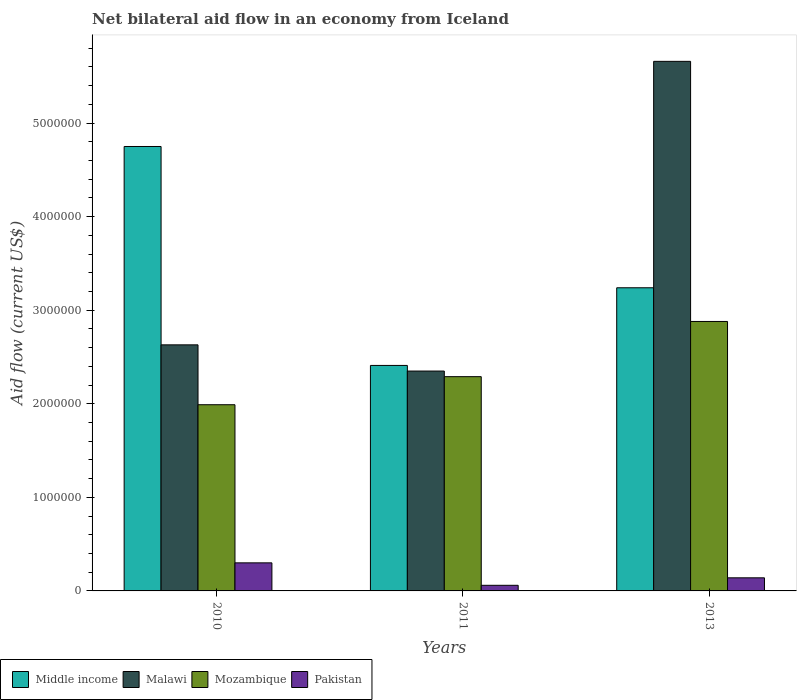How many different coloured bars are there?
Your response must be concise. 4. How many bars are there on the 1st tick from the left?
Provide a short and direct response. 4. How many bars are there on the 3rd tick from the right?
Keep it short and to the point. 4. What is the label of the 3rd group of bars from the left?
Provide a short and direct response. 2013. In how many cases, is the number of bars for a given year not equal to the number of legend labels?
Keep it short and to the point. 0. What is the net bilateral aid flow in Malawi in 2013?
Offer a terse response. 5.66e+06. Across all years, what is the maximum net bilateral aid flow in Malawi?
Your answer should be compact. 5.66e+06. What is the total net bilateral aid flow in Mozambique in the graph?
Your answer should be very brief. 7.16e+06. What is the difference between the net bilateral aid flow in Mozambique in 2010 and the net bilateral aid flow in Malawi in 2013?
Your response must be concise. -3.67e+06. What is the average net bilateral aid flow in Mozambique per year?
Your answer should be very brief. 2.39e+06. In the year 2010, what is the difference between the net bilateral aid flow in Mozambique and net bilateral aid flow in Malawi?
Provide a short and direct response. -6.40e+05. What is the ratio of the net bilateral aid flow in Malawi in 2010 to that in 2013?
Give a very brief answer. 0.46. Is the net bilateral aid flow in Mozambique in 2011 less than that in 2013?
Offer a terse response. Yes. Is the difference between the net bilateral aid flow in Mozambique in 2010 and 2011 greater than the difference between the net bilateral aid flow in Malawi in 2010 and 2011?
Make the answer very short. No. What is the difference between the highest and the second highest net bilateral aid flow in Mozambique?
Provide a succinct answer. 5.90e+05. In how many years, is the net bilateral aid flow in Mozambique greater than the average net bilateral aid flow in Mozambique taken over all years?
Offer a terse response. 1. What does the 1st bar from the left in 2013 represents?
Offer a very short reply. Middle income. What is the difference between two consecutive major ticks on the Y-axis?
Provide a short and direct response. 1.00e+06. Are the values on the major ticks of Y-axis written in scientific E-notation?
Provide a succinct answer. No. Does the graph contain grids?
Your response must be concise. No. Where does the legend appear in the graph?
Make the answer very short. Bottom left. How many legend labels are there?
Offer a very short reply. 4. How are the legend labels stacked?
Keep it short and to the point. Horizontal. What is the title of the graph?
Offer a very short reply. Net bilateral aid flow in an economy from Iceland. Does "Latvia" appear as one of the legend labels in the graph?
Make the answer very short. No. What is the Aid flow (current US$) of Middle income in 2010?
Keep it short and to the point. 4.75e+06. What is the Aid flow (current US$) of Malawi in 2010?
Your answer should be compact. 2.63e+06. What is the Aid flow (current US$) of Mozambique in 2010?
Your answer should be very brief. 1.99e+06. What is the Aid flow (current US$) in Pakistan in 2010?
Provide a succinct answer. 3.00e+05. What is the Aid flow (current US$) of Middle income in 2011?
Make the answer very short. 2.41e+06. What is the Aid flow (current US$) in Malawi in 2011?
Provide a short and direct response. 2.35e+06. What is the Aid flow (current US$) in Mozambique in 2011?
Your answer should be very brief. 2.29e+06. What is the Aid flow (current US$) in Middle income in 2013?
Make the answer very short. 3.24e+06. What is the Aid flow (current US$) in Malawi in 2013?
Ensure brevity in your answer.  5.66e+06. What is the Aid flow (current US$) in Mozambique in 2013?
Ensure brevity in your answer.  2.88e+06. What is the Aid flow (current US$) in Pakistan in 2013?
Offer a terse response. 1.40e+05. Across all years, what is the maximum Aid flow (current US$) of Middle income?
Provide a short and direct response. 4.75e+06. Across all years, what is the maximum Aid flow (current US$) in Malawi?
Provide a short and direct response. 5.66e+06. Across all years, what is the maximum Aid flow (current US$) of Mozambique?
Keep it short and to the point. 2.88e+06. Across all years, what is the maximum Aid flow (current US$) in Pakistan?
Your answer should be compact. 3.00e+05. Across all years, what is the minimum Aid flow (current US$) of Middle income?
Give a very brief answer. 2.41e+06. Across all years, what is the minimum Aid flow (current US$) in Malawi?
Offer a terse response. 2.35e+06. Across all years, what is the minimum Aid flow (current US$) in Mozambique?
Your response must be concise. 1.99e+06. What is the total Aid flow (current US$) of Middle income in the graph?
Offer a very short reply. 1.04e+07. What is the total Aid flow (current US$) of Malawi in the graph?
Provide a short and direct response. 1.06e+07. What is the total Aid flow (current US$) of Mozambique in the graph?
Provide a short and direct response. 7.16e+06. What is the difference between the Aid flow (current US$) in Middle income in 2010 and that in 2011?
Provide a succinct answer. 2.34e+06. What is the difference between the Aid flow (current US$) of Malawi in 2010 and that in 2011?
Your answer should be very brief. 2.80e+05. What is the difference between the Aid flow (current US$) of Mozambique in 2010 and that in 2011?
Keep it short and to the point. -3.00e+05. What is the difference between the Aid flow (current US$) in Pakistan in 2010 and that in 2011?
Offer a terse response. 2.40e+05. What is the difference between the Aid flow (current US$) in Middle income in 2010 and that in 2013?
Ensure brevity in your answer.  1.51e+06. What is the difference between the Aid flow (current US$) of Malawi in 2010 and that in 2013?
Provide a succinct answer. -3.03e+06. What is the difference between the Aid flow (current US$) in Mozambique in 2010 and that in 2013?
Make the answer very short. -8.90e+05. What is the difference between the Aid flow (current US$) in Pakistan in 2010 and that in 2013?
Your answer should be very brief. 1.60e+05. What is the difference between the Aid flow (current US$) of Middle income in 2011 and that in 2013?
Provide a short and direct response. -8.30e+05. What is the difference between the Aid flow (current US$) in Malawi in 2011 and that in 2013?
Provide a succinct answer. -3.31e+06. What is the difference between the Aid flow (current US$) of Mozambique in 2011 and that in 2013?
Offer a very short reply. -5.90e+05. What is the difference between the Aid flow (current US$) of Pakistan in 2011 and that in 2013?
Keep it short and to the point. -8.00e+04. What is the difference between the Aid flow (current US$) in Middle income in 2010 and the Aid flow (current US$) in Malawi in 2011?
Provide a short and direct response. 2.40e+06. What is the difference between the Aid flow (current US$) of Middle income in 2010 and the Aid flow (current US$) of Mozambique in 2011?
Offer a terse response. 2.46e+06. What is the difference between the Aid flow (current US$) of Middle income in 2010 and the Aid flow (current US$) of Pakistan in 2011?
Provide a succinct answer. 4.69e+06. What is the difference between the Aid flow (current US$) of Malawi in 2010 and the Aid flow (current US$) of Pakistan in 2011?
Your answer should be very brief. 2.57e+06. What is the difference between the Aid flow (current US$) in Mozambique in 2010 and the Aid flow (current US$) in Pakistan in 2011?
Your response must be concise. 1.93e+06. What is the difference between the Aid flow (current US$) in Middle income in 2010 and the Aid flow (current US$) in Malawi in 2013?
Your answer should be very brief. -9.10e+05. What is the difference between the Aid flow (current US$) in Middle income in 2010 and the Aid flow (current US$) in Mozambique in 2013?
Your answer should be compact. 1.87e+06. What is the difference between the Aid flow (current US$) in Middle income in 2010 and the Aid flow (current US$) in Pakistan in 2013?
Make the answer very short. 4.61e+06. What is the difference between the Aid flow (current US$) of Malawi in 2010 and the Aid flow (current US$) of Pakistan in 2013?
Provide a short and direct response. 2.49e+06. What is the difference between the Aid flow (current US$) in Mozambique in 2010 and the Aid flow (current US$) in Pakistan in 2013?
Provide a short and direct response. 1.85e+06. What is the difference between the Aid flow (current US$) in Middle income in 2011 and the Aid flow (current US$) in Malawi in 2013?
Your answer should be compact. -3.25e+06. What is the difference between the Aid flow (current US$) in Middle income in 2011 and the Aid flow (current US$) in Mozambique in 2013?
Give a very brief answer. -4.70e+05. What is the difference between the Aid flow (current US$) in Middle income in 2011 and the Aid flow (current US$) in Pakistan in 2013?
Your answer should be compact. 2.27e+06. What is the difference between the Aid flow (current US$) in Malawi in 2011 and the Aid flow (current US$) in Mozambique in 2013?
Provide a short and direct response. -5.30e+05. What is the difference between the Aid flow (current US$) of Malawi in 2011 and the Aid flow (current US$) of Pakistan in 2013?
Offer a terse response. 2.21e+06. What is the difference between the Aid flow (current US$) in Mozambique in 2011 and the Aid flow (current US$) in Pakistan in 2013?
Your answer should be compact. 2.15e+06. What is the average Aid flow (current US$) of Middle income per year?
Give a very brief answer. 3.47e+06. What is the average Aid flow (current US$) of Malawi per year?
Offer a terse response. 3.55e+06. What is the average Aid flow (current US$) of Mozambique per year?
Ensure brevity in your answer.  2.39e+06. What is the average Aid flow (current US$) of Pakistan per year?
Ensure brevity in your answer.  1.67e+05. In the year 2010, what is the difference between the Aid flow (current US$) in Middle income and Aid flow (current US$) in Malawi?
Make the answer very short. 2.12e+06. In the year 2010, what is the difference between the Aid flow (current US$) in Middle income and Aid flow (current US$) in Mozambique?
Keep it short and to the point. 2.76e+06. In the year 2010, what is the difference between the Aid flow (current US$) in Middle income and Aid flow (current US$) in Pakistan?
Make the answer very short. 4.45e+06. In the year 2010, what is the difference between the Aid flow (current US$) of Malawi and Aid flow (current US$) of Mozambique?
Keep it short and to the point. 6.40e+05. In the year 2010, what is the difference between the Aid flow (current US$) in Malawi and Aid flow (current US$) in Pakistan?
Offer a very short reply. 2.33e+06. In the year 2010, what is the difference between the Aid flow (current US$) in Mozambique and Aid flow (current US$) in Pakistan?
Your response must be concise. 1.69e+06. In the year 2011, what is the difference between the Aid flow (current US$) in Middle income and Aid flow (current US$) in Mozambique?
Provide a short and direct response. 1.20e+05. In the year 2011, what is the difference between the Aid flow (current US$) of Middle income and Aid flow (current US$) of Pakistan?
Your answer should be very brief. 2.35e+06. In the year 2011, what is the difference between the Aid flow (current US$) in Malawi and Aid flow (current US$) in Pakistan?
Give a very brief answer. 2.29e+06. In the year 2011, what is the difference between the Aid flow (current US$) in Mozambique and Aid flow (current US$) in Pakistan?
Provide a succinct answer. 2.23e+06. In the year 2013, what is the difference between the Aid flow (current US$) in Middle income and Aid flow (current US$) in Malawi?
Keep it short and to the point. -2.42e+06. In the year 2013, what is the difference between the Aid flow (current US$) of Middle income and Aid flow (current US$) of Mozambique?
Your answer should be compact. 3.60e+05. In the year 2013, what is the difference between the Aid flow (current US$) of Middle income and Aid flow (current US$) of Pakistan?
Your response must be concise. 3.10e+06. In the year 2013, what is the difference between the Aid flow (current US$) of Malawi and Aid flow (current US$) of Mozambique?
Make the answer very short. 2.78e+06. In the year 2013, what is the difference between the Aid flow (current US$) of Malawi and Aid flow (current US$) of Pakistan?
Your response must be concise. 5.52e+06. In the year 2013, what is the difference between the Aid flow (current US$) of Mozambique and Aid flow (current US$) of Pakistan?
Your answer should be very brief. 2.74e+06. What is the ratio of the Aid flow (current US$) in Middle income in 2010 to that in 2011?
Your answer should be very brief. 1.97. What is the ratio of the Aid flow (current US$) of Malawi in 2010 to that in 2011?
Offer a terse response. 1.12. What is the ratio of the Aid flow (current US$) in Mozambique in 2010 to that in 2011?
Make the answer very short. 0.87. What is the ratio of the Aid flow (current US$) in Middle income in 2010 to that in 2013?
Keep it short and to the point. 1.47. What is the ratio of the Aid flow (current US$) in Malawi in 2010 to that in 2013?
Provide a short and direct response. 0.46. What is the ratio of the Aid flow (current US$) of Mozambique in 2010 to that in 2013?
Keep it short and to the point. 0.69. What is the ratio of the Aid flow (current US$) in Pakistan in 2010 to that in 2013?
Give a very brief answer. 2.14. What is the ratio of the Aid flow (current US$) of Middle income in 2011 to that in 2013?
Your answer should be compact. 0.74. What is the ratio of the Aid flow (current US$) in Malawi in 2011 to that in 2013?
Offer a terse response. 0.42. What is the ratio of the Aid flow (current US$) in Mozambique in 2011 to that in 2013?
Provide a succinct answer. 0.8. What is the ratio of the Aid flow (current US$) of Pakistan in 2011 to that in 2013?
Your response must be concise. 0.43. What is the difference between the highest and the second highest Aid flow (current US$) in Middle income?
Offer a very short reply. 1.51e+06. What is the difference between the highest and the second highest Aid flow (current US$) in Malawi?
Keep it short and to the point. 3.03e+06. What is the difference between the highest and the second highest Aid flow (current US$) of Mozambique?
Keep it short and to the point. 5.90e+05. What is the difference between the highest and the second highest Aid flow (current US$) of Pakistan?
Give a very brief answer. 1.60e+05. What is the difference between the highest and the lowest Aid flow (current US$) in Middle income?
Your answer should be very brief. 2.34e+06. What is the difference between the highest and the lowest Aid flow (current US$) of Malawi?
Keep it short and to the point. 3.31e+06. What is the difference between the highest and the lowest Aid flow (current US$) of Mozambique?
Provide a succinct answer. 8.90e+05. 